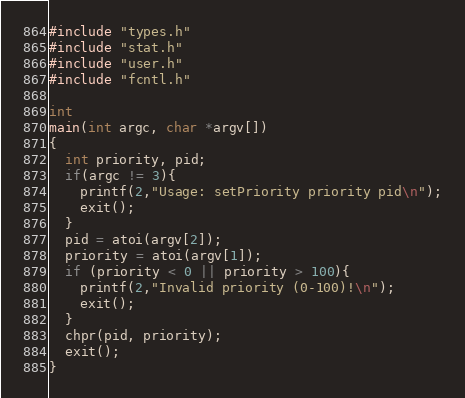Convert code to text. <code><loc_0><loc_0><loc_500><loc_500><_C_>#include "types.h"
#include "stat.h"
#include "user.h"
#include "fcntl.h"

int
main(int argc, char *argv[])
{
  int priority, pid;
  if(argc != 3){
    printf(2,"Usage: setPriority priority pid\n");
    exit();
  }
  pid = atoi(argv[2]);
  priority = atoi(argv[1]);
  if (priority < 0 || priority > 100){
    printf(2,"Invalid priority (0-100)!\n");
    exit();
  }
  chpr(pid, priority);
  exit();
}</code> 